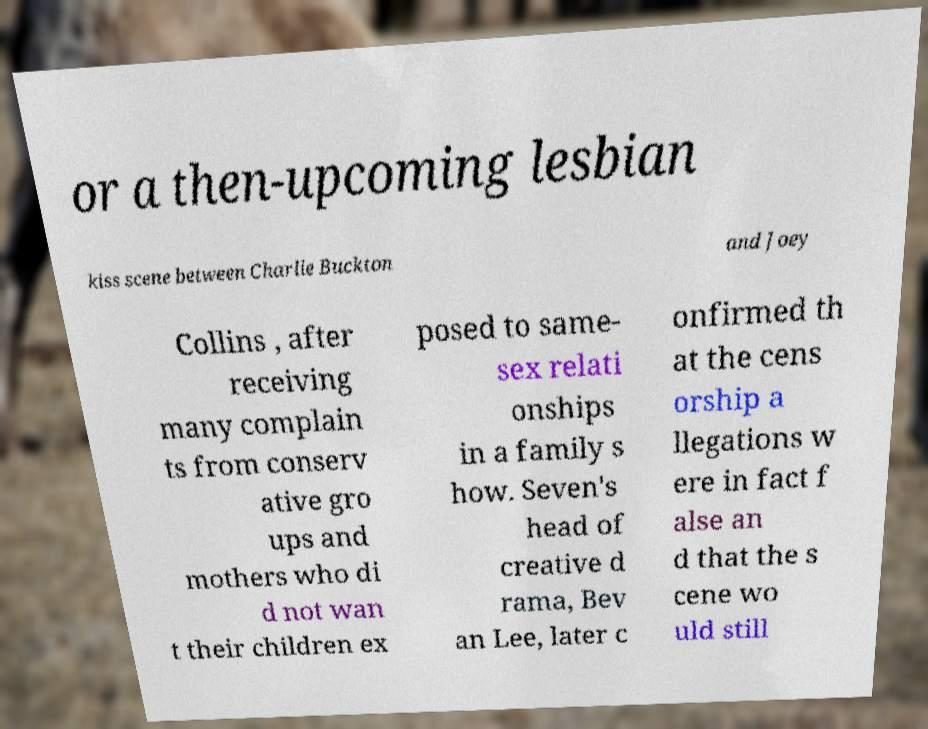There's text embedded in this image that I need extracted. Can you transcribe it verbatim? or a then-upcoming lesbian kiss scene between Charlie Buckton and Joey Collins , after receiving many complain ts from conserv ative gro ups and mothers who di d not wan t their children ex posed to same- sex relati onships in a family s how. Seven's head of creative d rama, Bev an Lee, later c onfirmed th at the cens orship a llegations w ere in fact f alse an d that the s cene wo uld still 